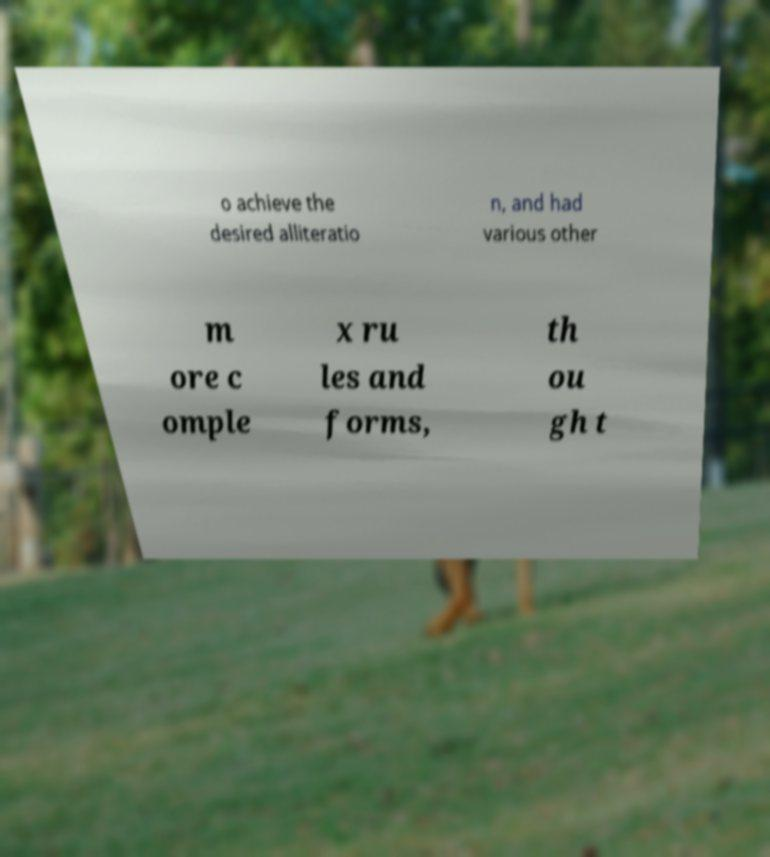There's text embedded in this image that I need extracted. Can you transcribe it verbatim? o achieve the desired alliteratio n, and had various other m ore c omple x ru les and forms, th ou gh t 